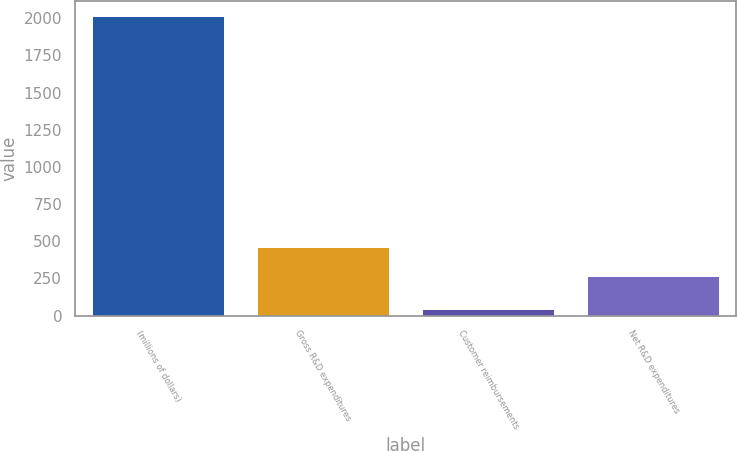Convert chart. <chart><loc_0><loc_0><loc_500><loc_500><bar_chart><fcel>(millions of dollars)<fcel>Gross R&D expenditures<fcel>Customer reimbursements<fcel>Net R&D expenditures<nl><fcel>2012<fcel>462.76<fcel>43.4<fcel>265.9<nl></chart> 